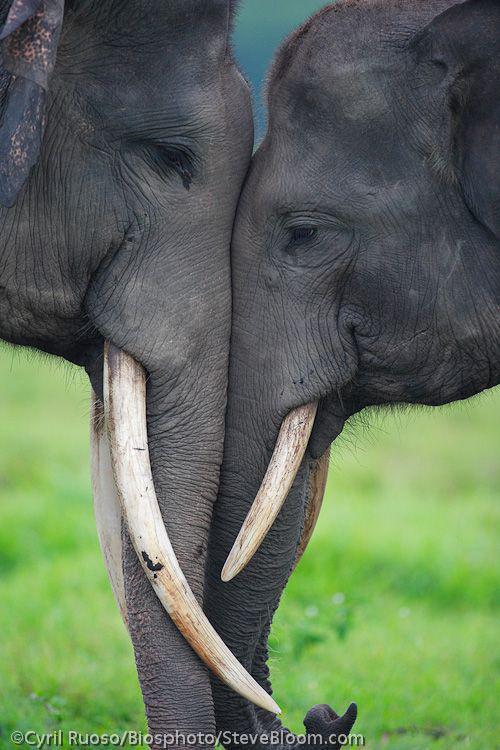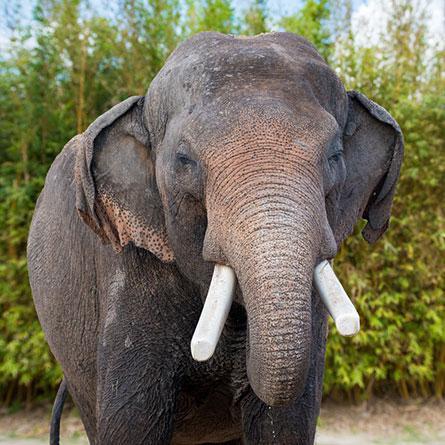The first image is the image on the left, the second image is the image on the right. Considering the images on both sides, is "The left image contains two elephants touching their heads to each others." valid? Answer yes or no. Yes. The first image is the image on the left, the second image is the image on the right. Analyze the images presented: Is the assertion "All elephants shown have tusks and exactly one elephant faces the camera." valid? Answer yes or no. Yes. 